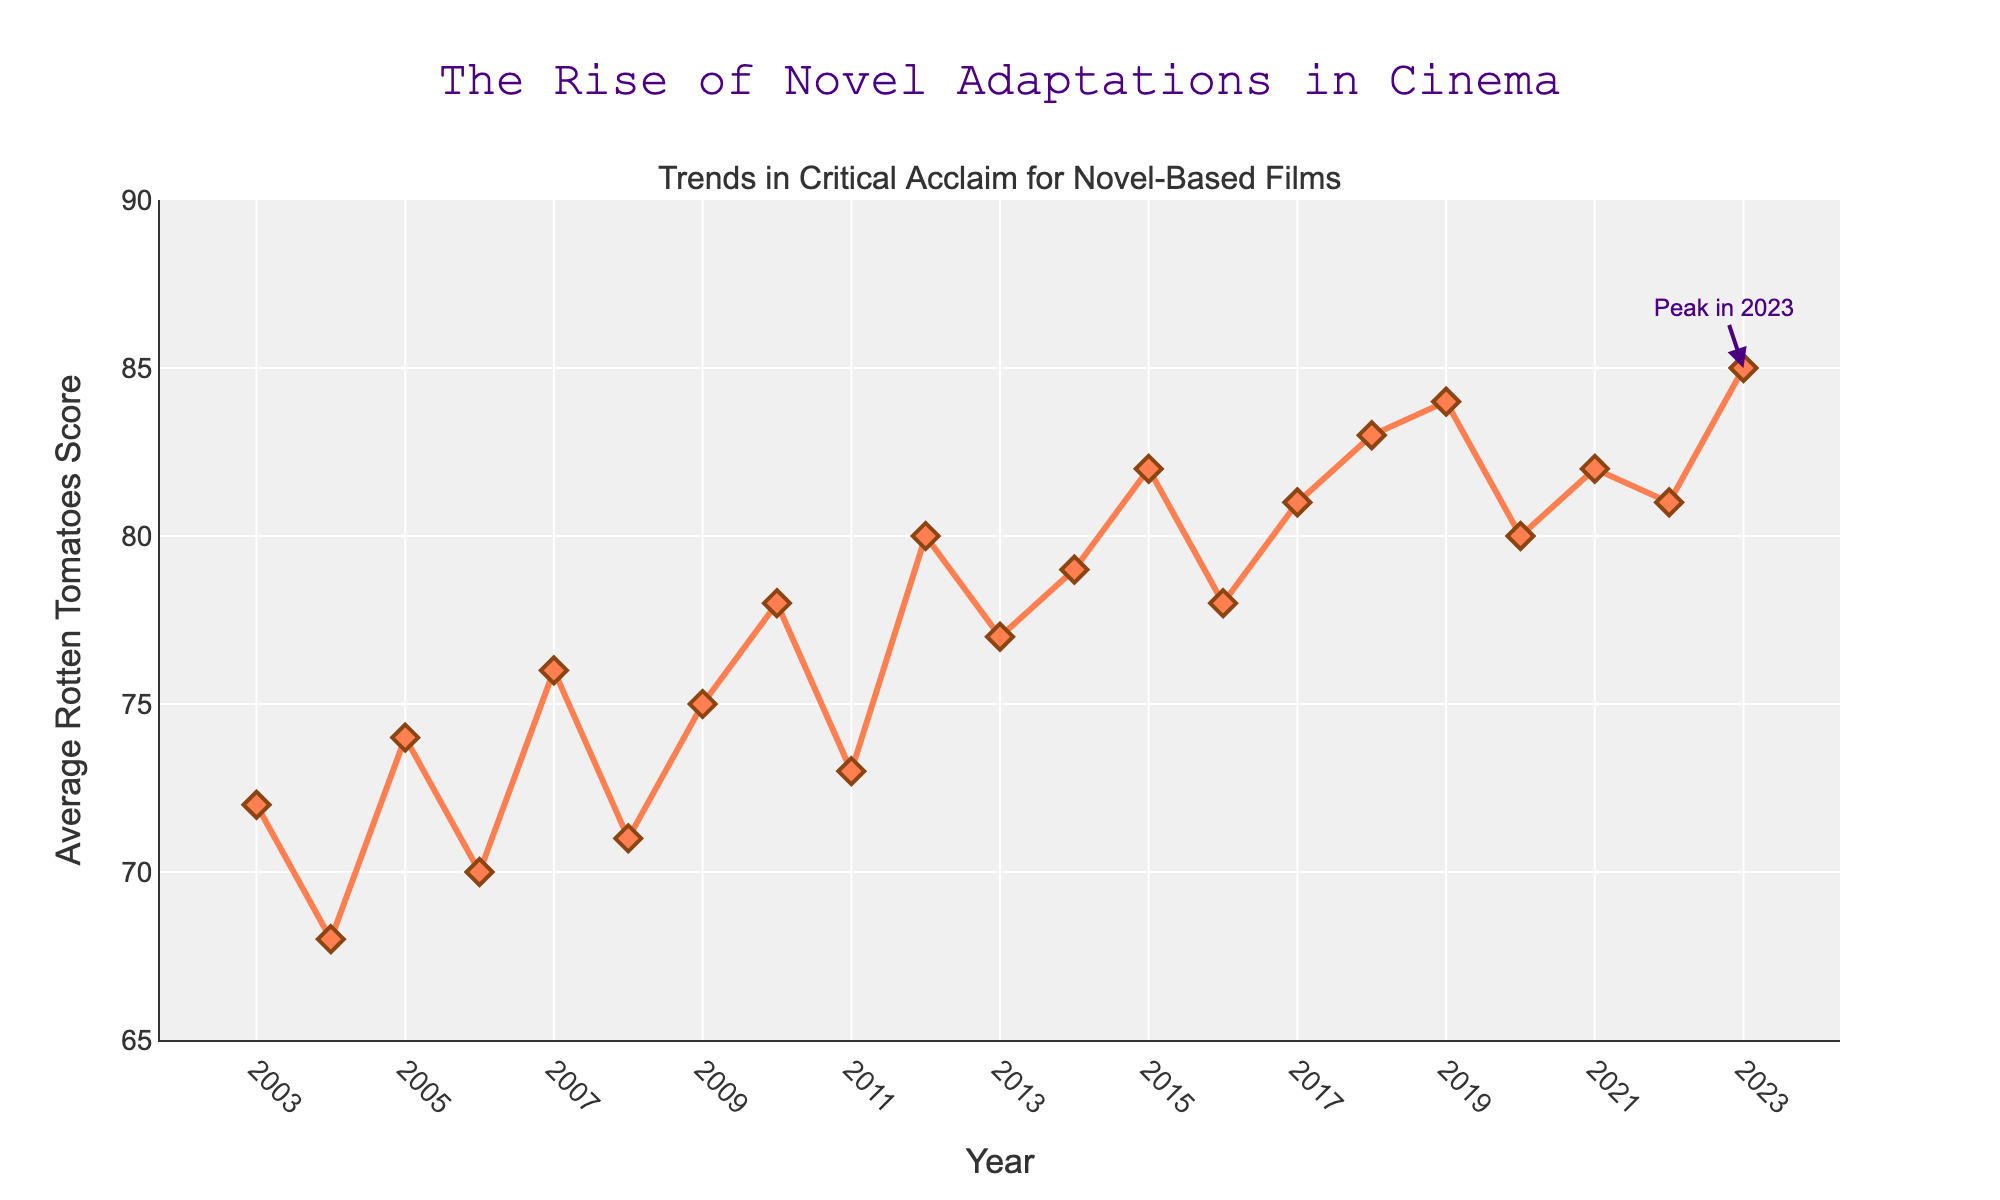What is the title of the figure? The title is located at the top center of the figure. It reads "The Rise of Novel Adaptations in Cinema."
Answer: The Rise of Novel Adaptations in Cinema What is the highest average Rotten Tomatoes score in the given period? Locate the peak point on the graph's y-axis, which represents the highest Rotten Tomatoes score. The highest value is marked at the year 2023.
Answer: 85 How did the average Rotten Tomatoes score change from 2004 to 2010? Observe the values for 2004 (68) and 2010 (78) on the y-axis. Calculate the difference: 78 - 68. This shows an increase in the score by 10 points.
Answer: Increased by 10 points What was the trend in average Rotten Tomatoes scores during the years 2012 to 2018? For these years, observe the plotted line. From 2012 to 2018, the scores generally increase with a slight fluctuation. The scores move from 80 to 83.
Answer: Upward trend Which year had a higher average Rotten Tomatoes score, 2008 or 2012? Compare the markers for 2008 and 2012. The score for 2008 is 71, and for 2012, it is 80. So, 2012 had a higher score.
Answer: 2012 What is the overall trend in average Rotten Tomatoes scores from 2003 to 2023? Analyze the plot from the beginning to the end. The scores increase from 72 in 2003 to 85 in 2023, indicating an overall upward trend.
Answer: Upward trend Did the average Rotten Tomatoes score ever decrease for three consecutive years? Scan the plot for continuous declines for three years in a row. No such trend appears as the scores generally fluctuate or increase.
Answer: No Which year marked a peak in average Rotten Tomatoes score, as noted by an annotation? Identify the annotation "Peak in 2023" on the plot, which marks the peak value of 85 in the year 2023.
Answer: 2023 What is the approximate range of average Rotten Tomatoes scores in the given period? Determine the minimum and maximum scores from the y-axis. The minimum is slightly above 65, and the maximum is 85. The approximate range is from 65 to 85.
Answer: 65 to 85 